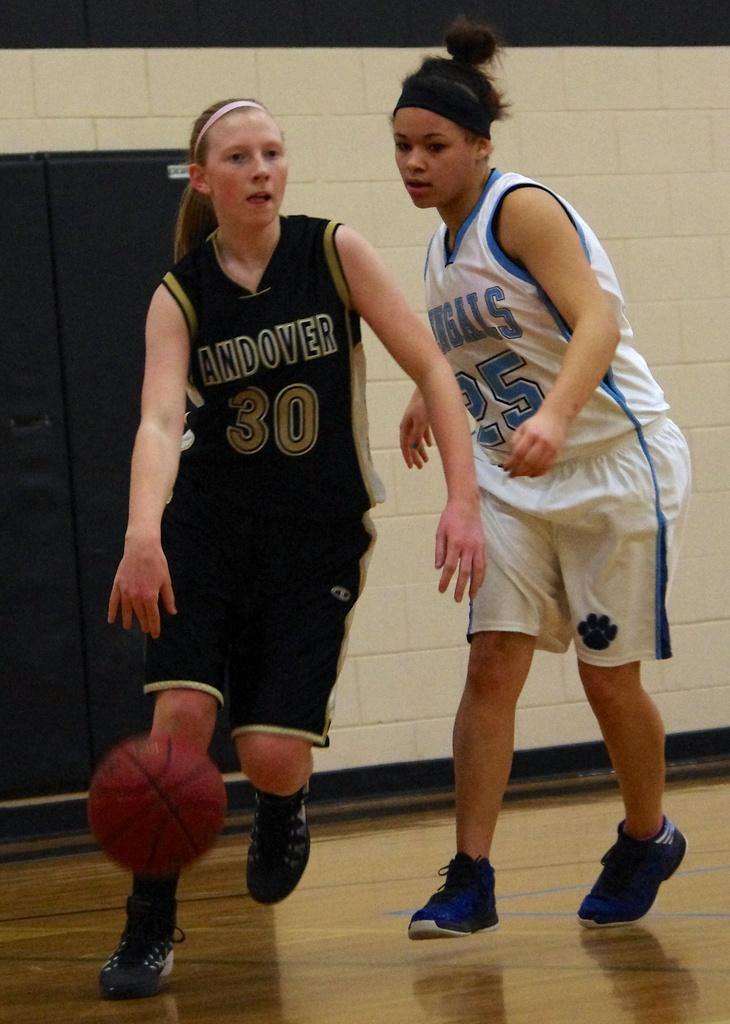How many people are in the image? There are two women in the image. What are the women doing in the image? The women are running on the floor. Is there any object in the air in the image? Yes, there is a ball in the air. What can be seen in the background of the image? There is a wall and a cupboard in the background of the image. What type of sail can be seen on the women's clothing in the image? There is no sail present on the women's clothing in the image. How many pockets are visible on the women's clothing in the image? There is no information about pockets on the women's clothing in the image. 